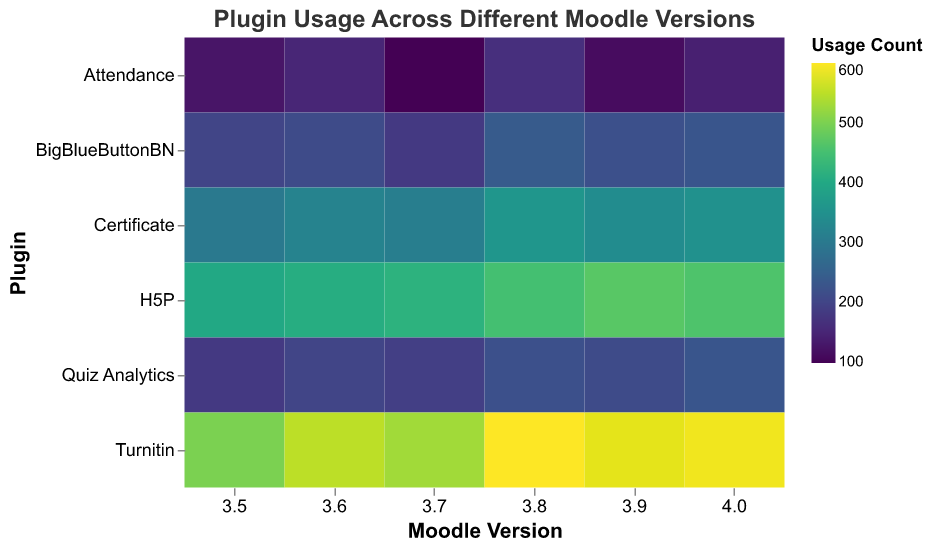Which Moodle version has the highest usage for the Turnitin plugin? First, locate the "Turnitin" row on the y-axis. Then, scan horizontally across the versions to find the highest number in that row. The highest number is 600 for version 3.8.
Answer: 3.8 What's the average usage count for the BigBlueButtonBN plugin across all versions? Add the usage counts for BigBlueButtonBN (200 + 210 + 180 + 240 + 220 + 230) and then divide by the number of versions (6). The total sum is 1280, and the average is 1280 / 6 = 213.33.
Answer: 213.33 Which plugin has the highest overall usage count across all Moodle versions? First, compare the usage counts across all plugins and versions to find the respective sums per plugin. "Turnitin" has the highest single value of 600, and its overall high values indicate it is likely the highest.
Answer: Turnitin For the H5P plugin, which Moodle version shows the maximum usage count? Locate the "H5P" row and scan horizontally to find the highest usage count. The maximum count is 470 for version 3.9.
Answer: 3.9 How does the usage of the Certificate plugin in version 3.7 compare to its usage in version 4.0? First, find the usage counts for the Certificate plugin in versions 3.7 (310) and 4.0 (350). Then compare the two values. Usage in 4.0 (350) is greater than in 3.7 (310).
Answer: 4.0 > 3.7 What is the total combined usage count for all plugins in Moodle version 4.0? Sum the usage counts for all plugins in version 4.0 (140 + 230 + 350 + 460 + 230 + 590). The total is 2000.
Answer: 2000 Which plugin shows a decreasing trend in usage count from version 3.5 to 3.7? Look for a plugin whose usage count decreases across the versions 3.5 to 3.7. "Attendance" has a decreasing trend (124 to 98), as does "BigBlueButtonBN" (200 to 180).
Answer: Attendance What is the range of usage counts for the H5P plugin across all versions? Find the minimum and maximum usage counts for H5P (400 and 470) and calculate the range as 470 - 400. The range is 70.
Answer: 70 On average, what is the usage count difference between the Certificate and Quiz Analytics plugins across all versions? Calculate the total counts for Certificate (300+320+310+360+340+350=1980) and Quiz Analytics (180+200+190+220+210+230=1230). Find the average counts (1980/6 and 1230/6), then calculate the average difference. The average difference is (330 - 205) = 125.
Answer: 125 Between versions 3.9 and 4.0, which plugin shows the least increase in usage count? Find the difference in usage counts for all plugins between versions 3.9 and 4.0 and identify the smallest positive difference. "H5P" shows a decrease (470 to 460), but for a positive change, "Quiz Analytics" shows the smallest increase (210 to 230, difference of 20).
Answer: Quiz Analytics 